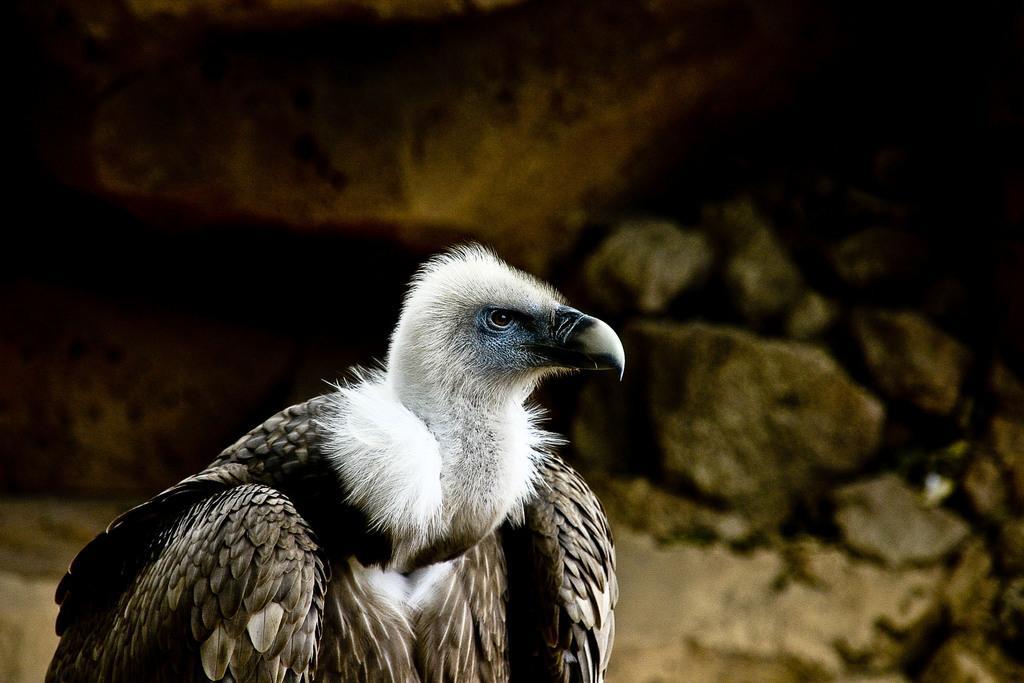Describe this image in one or two sentences. In this image we can see a vulture. In the background there are stones. 